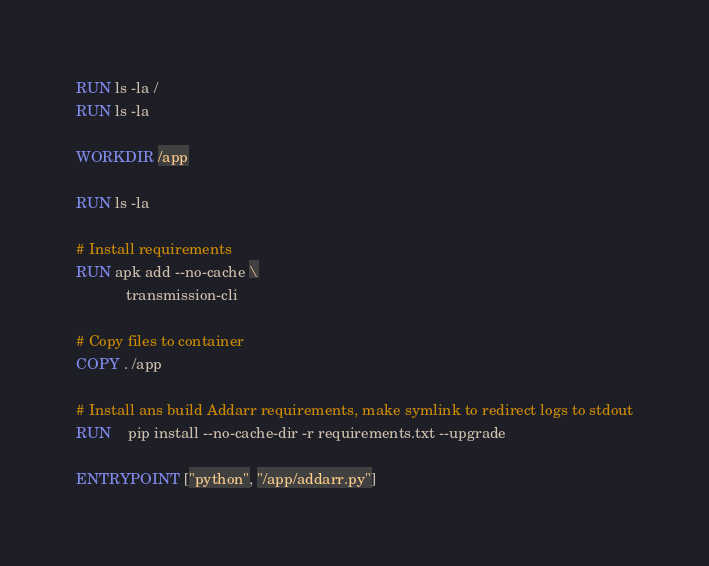<code> <loc_0><loc_0><loc_500><loc_500><_Dockerfile_>
RUN ls -la /
RUN ls -la

WORKDIR /app

RUN ls -la

# Install requirements
RUN apk add --no-cache \
            transmission-cli

# Copy files to container
COPY . /app

# Install ans build Addarr requirements, make symlink to redirect logs to stdout
RUN	pip install --no-cache-dir -r requirements.txt --upgrade

ENTRYPOINT ["python", "/app/addarr.py"]
</code> 